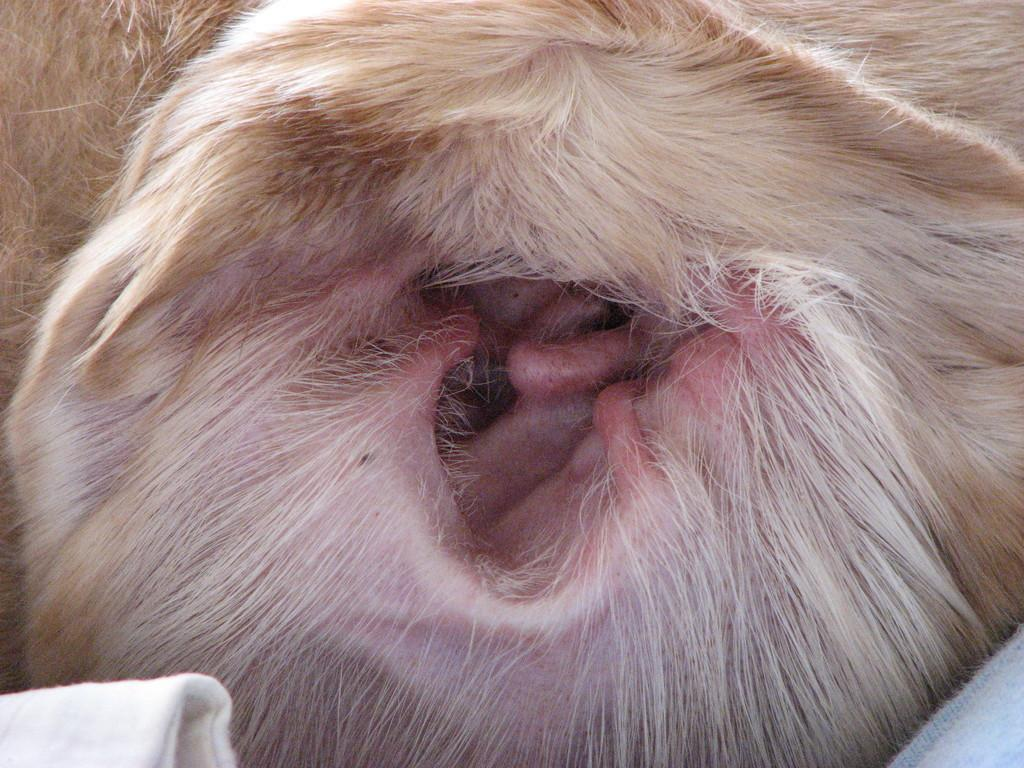What type of animal's ear is visible in the image? The specific type of animal cannot be determined from the image. Can you describe the appearance of the ear in the image? The ear appears to be furry and has a distinct shape. What other parts of the animal can be seen in the image? The image only shows the ear of the animal. How many apples are being held by the animal in the image? There is no animal holding apples in the image; it only shows the ear of an animal. 